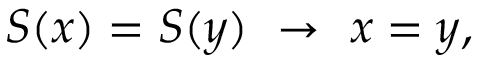Convert formula to latex. <formula><loc_0><loc_0><loc_500><loc_500>S ( x ) = S ( y ) \to x = y ,</formula> 